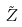<formula> <loc_0><loc_0><loc_500><loc_500>\tilde { Z }</formula> 